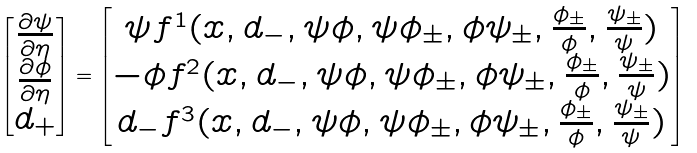Convert formula to latex. <formula><loc_0><loc_0><loc_500><loc_500>\begin{bmatrix} \frac { \partial \psi } { \partial \eta } \\ \frac { \partial \phi } { \partial \eta } \\ d _ { + } \end{bmatrix} = \begin{bmatrix} \psi f ^ { 1 } ( x , d _ { - } , \psi \phi , \psi \phi _ { \pm } , \phi \psi _ { \pm } , \frac { \phi _ { \pm } } { \phi } , \frac { \psi _ { \pm } } { \psi } ) \\ - \phi f ^ { 2 } ( x , d _ { - } , \psi \phi , \psi \phi _ { \pm } , \phi \psi _ { \pm } , \frac { \phi _ { \pm } } { \phi } , \frac { \psi _ { \pm } } { \psi } ) \\ d _ { - } f ^ { 3 } ( x , d _ { - } , \psi \phi , \psi \phi _ { \pm } , \phi \psi _ { \pm } , \frac { \phi _ { \pm } } { \phi } , \frac { \psi _ { \pm } } { \psi } ) \end{bmatrix}</formula> 